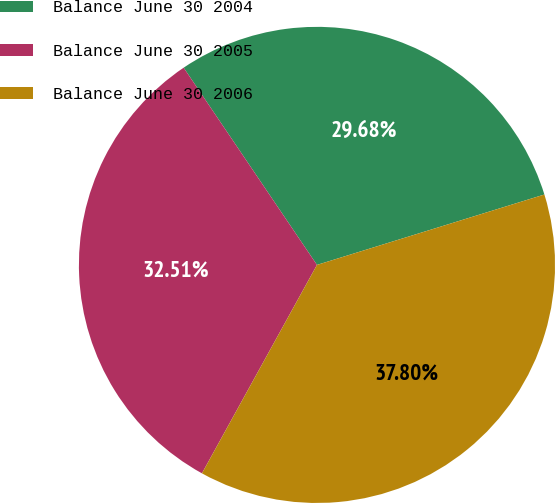Convert chart. <chart><loc_0><loc_0><loc_500><loc_500><pie_chart><fcel>Balance June 30 2004<fcel>Balance June 30 2005<fcel>Balance June 30 2006<nl><fcel>29.68%<fcel>32.51%<fcel>37.8%<nl></chart> 